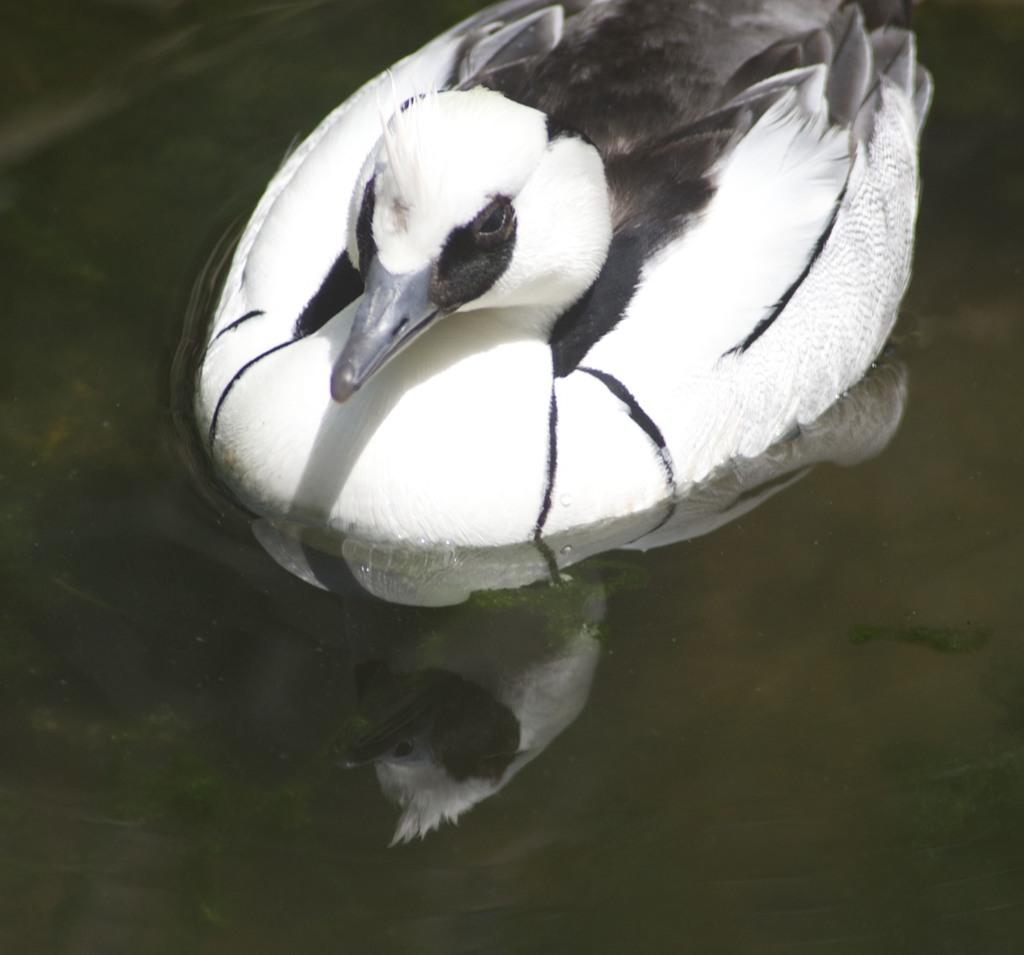What is the bird doing in the image? The bird is in the water. What colors can be seen on the bird? The bird has white and black colors. What type of shoe is floating in the water next to the bird? There is no shoe present in the image; it only features a bird in the water. 